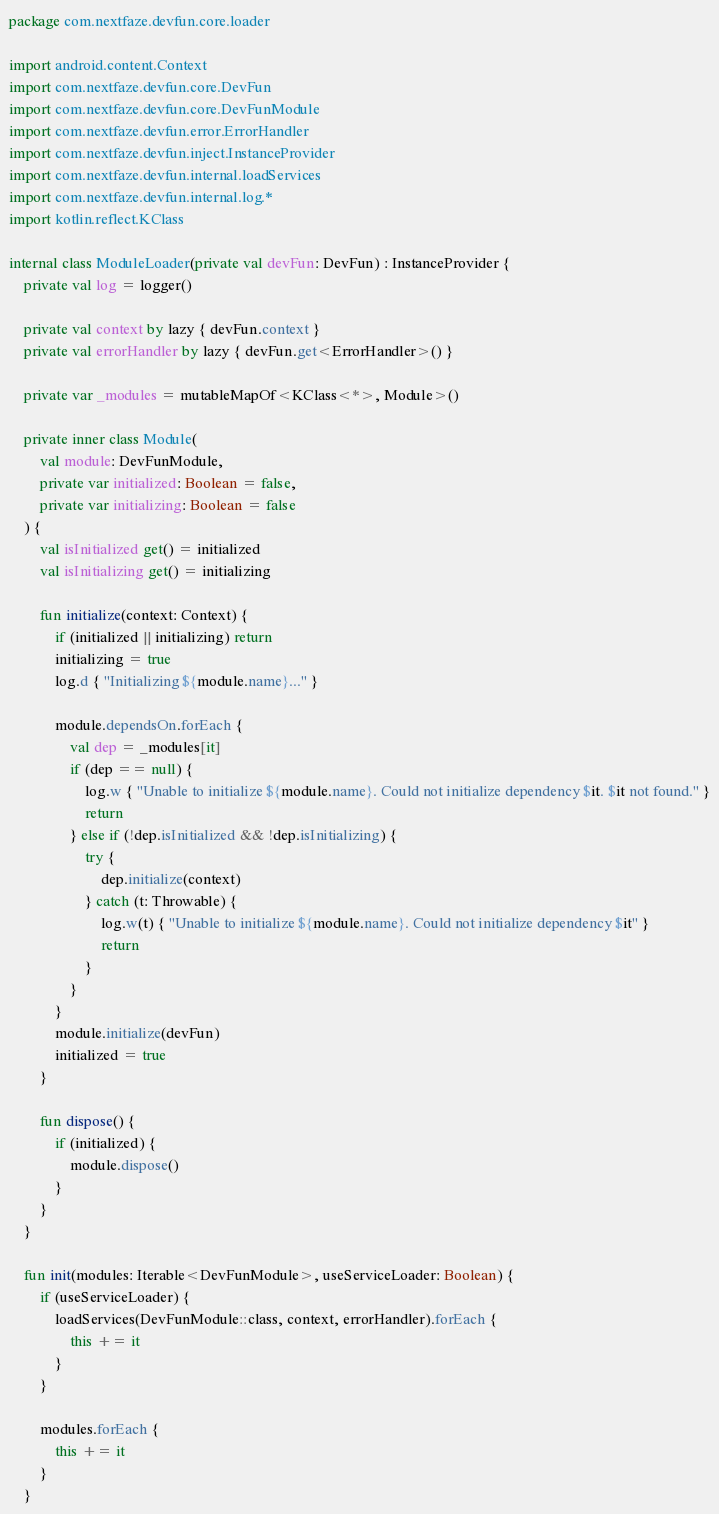<code> <loc_0><loc_0><loc_500><loc_500><_Kotlin_>package com.nextfaze.devfun.core.loader

import android.content.Context
import com.nextfaze.devfun.core.DevFun
import com.nextfaze.devfun.core.DevFunModule
import com.nextfaze.devfun.error.ErrorHandler
import com.nextfaze.devfun.inject.InstanceProvider
import com.nextfaze.devfun.internal.loadServices
import com.nextfaze.devfun.internal.log.*
import kotlin.reflect.KClass

internal class ModuleLoader(private val devFun: DevFun) : InstanceProvider {
    private val log = logger()

    private val context by lazy { devFun.context }
    private val errorHandler by lazy { devFun.get<ErrorHandler>() }

    private var _modules = mutableMapOf<KClass<*>, Module>()

    private inner class Module(
        val module: DevFunModule,
        private var initialized: Boolean = false,
        private var initializing: Boolean = false
    ) {
        val isInitialized get() = initialized
        val isInitializing get() = initializing

        fun initialize(context: Context) {
            if (initialized || initializing) return
            initializing = true
            log.d { "Initializing ${module.name}..." }

            module.dependsOn.forEach {
                val dep = _modules[it]
                if (dep == null) {
                    log.w { "Unable to initialize ${module.name}. Could not initialize dependency $it. $it not found." }
                    return
                } else if (!dep.isInitialized && !dep.isInitializing) {
                    try {
                        dep.initialize(context)
                    } catch (t: Throwable) {
                        log.w(t) { "Unable to initialize ${module.name}. Could not initialize dependency $it" }
                        return
                    }
                }
            }
            module.initialize(devFun)
            initialized = true
        }

        fun dispose() {
            if (initialized) {
                module.dispose()
            }
        }
    }

    fun init(modules: Iterable<DevFunModule>, useServiceLoader: Boolean) {
        if (useServiceLoader) {
            loadServices(DevFunModule::class, context, errorHandler).forEach {
                this += it
            }
        }

        modules.forEach {
            this += it
        }
    }
</code> 